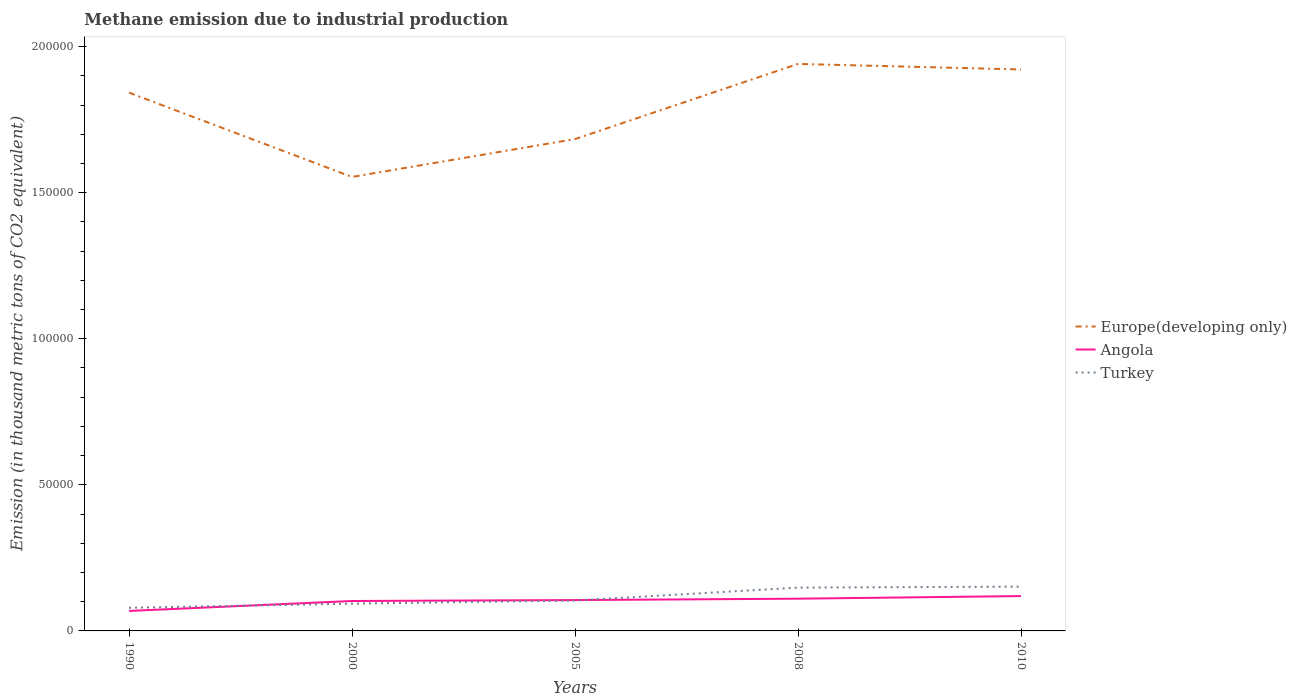How many different coloured lines are there?
Offer a terse response. 3. Does the line corresponding to Turkey intersect with the line corresponding to Angola?
Offer a terse response. Yes. Is the number of lines equal to the number of legend labels?
Your answer should be compact. Yes. Across all years, what is the maximum amount of methane emitted in Angola?
Make the answer very short. 6841.7. In which year was the amount of methane emitted in Europe(developing only) maximum?
Your answer should be very brief. 2000. What is the total amount of methane emitted in Europe(developing only) in the graph?
Your response must be concise. -9838.5. What is the difference between the highest and the second highest amount of methane emitted in Europe(developing only)?
Give a very brief answer. 3.87e+04. What is the difference between the highest and the lowest amount of methane emitted in Europe(developing only)?
Your response must be concise. 3. Are the values on the major ticks of Y-axis written in scientific E-notation?
Provide a succinct answer. No. Does the graph contain grids?
Provide a succinct answer. No. Where does the legend appear in the graph?
Your answer should be compact. Center right. How many legend labels are there?
Your answer should be very brief. 3. What is the title of the graph?
Give a very brief answer. Methane emission due to industrial production. Does "Pakistan" appear as one of the legend labels in the graph?
Your answer should be very brief. No. What is the label or title of the Y-axis?
Ensure brevity in your answer.  Emission (in thousand metric tons of CO2 equivalent). What is the Emission (in thousand metric tons of CO2 equivalent) in Europe(developing only) in 1990?
Ensure brevity in your answer.  1.84e+05. What is the Emission (in thousand metric tons of CO2 equivalent) of Angola in 1990?
Your answer should be compact. 6841.7. What is the Emission (in thousand metric tons of CO2 equivalent) of Turkey in 1990?
Ensure brevity in your answer.  7912.1. What is the Emission (in thousand metric tons of CO2 equivalent) in Europe(developing only) in 2000?
Provide a short and direct response. 1.55e+05. What is the Emission (in thousand metric tons of CO2 equivalent) of Angola in 2000?
Ensure brevity in your answer.  1.02e+04. What is the Emission (in thousand metric tons of CO2 equivalent) of Turkey in 2000?
Provide a short and direct response. 9337. What is the Emission (in thousand metric tons of CO2 equivalent) of Europe(developing only) in 2005?
Offer a very short reply. 1.68e+05. What is the Emission (in thousand metric tons of CO2 equivalent) of Angola in 2005?
Provide a succinct answer. 1.06e+04. What is the Emission (in thousand metric tons of CO2 equivalent) in Turkey in 2005?
Provide a succinct answer. 1.04e+04. What is the Emission (in thousand metric tons of CO2 equivalent) of Europe(developing only) in 2008?
Keep it short and to the point. 1.94e+05. What is the Emission (in thousand metric tons of CO2 equivalent) in Angola in 2008?
Provide a short and direct response. 1.10e+04. What is the Emission (in thousand metric tons of CO2 equivalent) of Turkey in 2008?
Your response must be concise. 1.48e+04. What is the Emission (in thousand metric tons of CO2 equivalent) in Europe(developing only) in 2010?
Your response must be concise. 1.92e+05. What is the Emission (in thousand metric tons of CO2 equivalent) of Angola in 2010?
Your response must be concise. 1.19e+04. What is the Emission (in thousand metric tons of CO2 equivalent) of Turkey in 2010?
Provide a short and direct response. 1.52e+04. Across all years, what is the maximum Emission (in thousand metric tons of CO2 equivalent) in Europe(developing only)?
Make the answer very short. 1.94e+05. Across all years, what is the maximum Emission (in thousand metric tons of CO2 equivalent) in Angola?
Ensure brevity in your answer.  1.19e+04. Across all years, what is the maximum Emission (in thousand metric tons of CO2 equivalent) in Turkey?
Your answer should be very brief. 1.52e+04. Across all years, what is the minimum Emission (in thousand metric tons of CO2 equivalent) of Europe(developing only)?
Offer a terse response. 1.55e+05. Across all years, what is the minimum Emission (in thousand metric tons of CO2 equivalent) in Angola?
Make the answer very short. 6841.7. Across all years, what is the minimum Emission (in thousand metric tons of CO2 equivalent) of Turkey?
Provide a succinct answer. 7912.1. What is the total Emission (in thousand metric tons of CO2 equivalent) of Europe(developing only) in the graph?
Your answer should be very brief. 8.94e+05. What is the total Emission (in thousand metric tons of CO2 equivalent) of Angola in the graph?
Give a very brief answer. 5.06e+04. What is the total Emission (in thousand metric tons of CO2 equivalent) in Turkey in the graph?
Ensure brevity in your answer.  5.76e+04. What is the difference between the Emission (in thousand metric tons of CO2 equivalent) in Europe(developing only) in 1990 and that in 2000?
Ensure brevity in your answer.  2.88e+04. What is the difference between the Emission (in thousand metric tons of CO2 equivalent) in Angola in 1990 and that in 2000?
Offer a very short reply. -3399.1. What is the difference between the Emission (in thousand metric tons of CO2 equivalent) of Turkey in 1990 and that in 2000?
Offer a terse response. -1424.9. What is the difference between the Emission (in thousand metric tons of CO2 equivalent) in Europe(developing only) in 1990 and that in 2005?
Your response must be concise. 1.59e+04. What is the difference between the Emission (in thousand metric tons of CO2 equivalent) of Angola in 1990 and that in 2005?
Make the answer very short. -3720.7. What is the difference between the Emission (in thousand metric tons of CO2 equivalent) of Turkey in 1990 and that in 2005?
Your response must be concise. -2494.3. What is the difference between the Emission (in thousand metric tons of CO2 equivalent) of Europe(developing only) in 1990 and that in 2008?
Your answer should be compact. -9838.5. What is the difference between the Emission (in thousand metric tons of CO2 equivalent) in Angola in 1990 and that in 2008?
Ensure brevity in your answer.  -4190.2. What is the difference between the Emission (in thousand metric tons of CO2 equivalent) of Turkey in 1990 and that in 2008?
Provide a succinct answer. -6910. What is the difference between the Emission (in thousand metric tons of CO2 equivalent) in Europe(developing only) in 1990 and that in 2010?
Offer a very short reply. -7940.9. What is the difference between the Emission (in thousand metric tons of CO2 equivalent) in Angola in 1990 and that in 2010?
Provide a short and direct response. -5084.3. What is the difference between the Emission (in thousand metric tons of CO2 equivalent) of Turkey in 1990 and that in 2010?
Your response must be concise. -7253.5. What is the difference between the Emission (in thousand metric tons of CO2 equivalent) of Europe(developing only) in 2000 and that in 2005?
Provide a short and direct response. -1.30e+04. What is the difference between the Emission (in thousand metric tons of CO2 equivalent) of Angola in 2000 and that in 2005?
Give a very brief answer. -321.6. What is the difference between the Emission (in thousand metric tons of CO2 equivalent) in Turkey in 2000 and that in 2005?
Your response must be concise. -1069.4. What is the difference between the Emission (in thousand metric tons of CO2 equivalent) of Europe(developing only) in 2000 and that in 2008?
Make the answer very short. -3.87e+04. What is the difference between the Emission (in thousand metric tons of CO2 equivalent) in Angola in 2000 and that in 2008?
Ensure brevity in your answer.  -791.1. What is the difference between the Emission (in thousand metric tons of CO2 equivalent) in Turkey in 2000 and that in 2008?
Your answer should be compact. -5485.1. What is the difference between the Emission (in thousand metric tons of CO2 equivalent) of Europe(developing only) in 2000 and that in 2010?
Give a very brief answer. -3.68e+04. What is the difference between the Emission (in thousand metric tons of CO2 equivalent) of Angola in 2000 and that in 2010?
Keep it short and to the point. -1685.2. What is the difference between the Emission (in thousand metric tons of CO2 equivalent) of Turkey in 2000 and that in 2010?
Offer a terse response. -5828.6. What is the difference between the Emission (in thousand metric tons of CO2 equivalent) in Europe(developing only) in 2005 and that in 2008?
Make the answer very short. -2.57e+04. What is the difference between the Emission (in thousand metric tons of CO2 equivalent) of Angola in 2005 and that in 2008?
Make the answer very short. -469.5. What is the difference between the Emission (in thousand metric tons of CO2 equivalent) of Turkey in 2005 and that in 2008?
Make the answer very short. -4415.7. What is the difference between the Emission (in thousand metric tons of CO2 equivalent) of Europe(developing only) in 2005 and that in 2010?
Offer a terse response. -2.38e+04. What is the difference between the Emission (in thousand metric tons of CO2 equivalent) of Angola in 2005 and that in 2010?
Your answer should be very brief. -1363.6. What is the difference between the Emission (in thousand metric tons of CO2 equivalent) in Turkey in 2005 and that in 2010?
Ensure brevity in your answer.  -4759.2. What is the difference between the Emission (in thousand metric tons of CO2 equivalent) of Europe(developing only) in 2008 and that in 2010?
Provide a short and direct response. 1897.6. What is the difference between the Emission (in thousand metric tons of CO2 equivalent) of Angola in 2008 and that in 2010?
Offer a very short reply. -894.1. What is the difference between the Emission (in thousand metric tons of CO2 equivalent) of Turkey in 2008 and that in 2010?
Your answer should be compact. -343.5. What is the difference between the Emission (in thousand metric tons of CO2 equivalent) in Europe(developing only) in 1990 and the Emission (in thousand metric tons of CO2 equivalent) in Angola in 2000?
Make the answer very short. 1.74e+05. What is the difference between the Emission (in thousand metric tons of CO2 equivalent) in Europe(developing only) in 1990 and the Emission (in thousand metric tons of CO2 equivalent) in Turkey in 2000?
Your response must be concise. 1.75e+05. What is the difference between the Emission (in thousand metric tons of CO2 equivalent) in Angola in 1990 and the Emission (in thousand metric tons of CO2 equivalent) in Turkey in 2000?
Your answer should be very brief. -2495.3. What is the difference between the Emission (in thousand metric tons of CO2 equivalent) in Europe(developing only) in 1990 and the Emission (in thousand metric tons of CO2 equivalent) in Angola in 2005?
Give a very brief answer. 1.74e+05. What is the difference between the Emission (in thousand metric tons of CO2 equivalent) in Europe(developing only) in 1990 and the Emission (in thousand metric tons of CO2 equivalent) in Turkey in 2005?
Make the answer very short. 1.74e+05. What is the difference between the Emission (in thousand metric tons of CO2 equivalent) of Angola in 1990 and the Emission (in thousand metric tons of CO2 equivalent) of Turkey in 2005?
Provide a short and direct response. -3564.7. What is the difference between the Emission (in thousand metric tons of CO2 equivalent) of Europe(developing only) in 1990 and the Emission (in thousand metric tons of CO2 equivalent) of Angola in 2008?
Provide a short and direct response. 1.73e+05. What is the difference between the Emission (in thousand metric tons of CO2 equivalent) in Europe(developing only) in 1990 and the Emission (in thousand metric tons of CO2 equivalent) in Turkey in 2008?
Provide a succinct answer. 1.69e+05. What is the difference between the Emission (in thousand metric tons of CO2 equivalent) of Angola in 1990 and the Emission (in thousand metric tons of CO2 equivalent) of Turkey in 2008?
Make the answer very short. -7980.4. What is the difference between the Emission (in thousand metric tons of CO2 equivalent) of Europe(developing only) in 1990 and the Emission (in thousand metric tons of CO2 equivalent) of Angola in 2010?
Your answer should be compact. 1.72e+05. What is the difference between the Emission (in thousand metric tons of CO2 equivalent) of Europe(developing only) in 1990 and the Emission (in thousand metric tons of CO2 equivalent) of Turkey in 2010?
Provide a short and direct response. 1.69e+05. What is the difference between the Emission (in thousand metric tons of CO2 equivalent) in Angola in 1990 and the Emission (in thousand metric tons of CO2 equivalent) in Turkey in 2010?
Offer a very short reply. -8323.9. What is the difference between the Emission (in thousand metric tons of CO2 equivalent) of Europe(developing only) in 2000 and the Emission (in thousand metric tons of CO2 equivalent) of Angola in 2005?
Make the answer very short. 1.45e+05. What is the difference between the Emission (in thousand metric tons of CO2 equivalent) in Europe(developing only) in 2000 and the Emission (in thousand metric tons of CO2 equivalent) in Turkey in 2005?
Your response must be concise. 1.45e+05. What is the difference between the Emission (in thousand metric tons of CO2 equivalent) in Angola in 2000 and the Emission (in thousand metric tons of CO2 equivalent) in Turkey in 2005?
Your answer should be very brief. -165.6. What is the difference between the Emission (in thousand metric tons of CO2 equivalent) of Europe(developing only) in 2000 and the Emission (in thousand metric tons of CO2 equivalent) of Angola in 2008?
Give a very brief answer. 1.44e+05. What is the difference between the Emission (in thousand metric tons of CO2 equivalent) of Europe(developing only) in 2000 and the Emission (in thousand metric tons of CO2 equivalent) of Turkey in 2008?
Provide a short and direct response. 1.41e+05. What is the difference between the Emission (in thousand metric tons of CO2 equivalent) in Angola in 2000 and the Emission (in thousand metric tons of CO2 equivalent) in Turkey in 2008?
Offer a terse response. -4581.3. What is the difference between the Emission (in thousand metric tons of CO2 equivalent) of Europe(developing only) in 2000 and the Emission (in thousand metric tons of CO2 equivalent) of Angola in 2010?
Give a very brief answer. 1.43e+05. What is the difference between the Emission (in thousand metric tons of CO2 equivalent) of Europe(developing only) in 2000 and the Emission (in thousand metric tons of CO2 equivalent) of Turkey in 2010?
Your response must be concise. 1.40e+05. What is the difference between the Emission (in thousand metric tons of CO2 equivalent) of Angola in 2000 and the Emission (in thousand metric tons of CO2 equivalent) of Turkey in 2010?
Your answer should be compact. -4924.8. What is the difference between the Emission (in thousand metric tons of CO2 equivalent) in Europe(developing only) in 2005 and the Emission (in thousand metric tons of CO2 equivalent) in Angola in 2008?
Offer a very short reply. 1.57e+05. What is the difference between the Emission (in thousand metric tons of CO2 equivalent) of Europe(developing only) in 2005 and the Emission (in thousand metric tons of CO2 equivalent) of Turkey in 2008?
Offer a very short reply. 1.54e+05. What is the difference between the Emission (in thousand metric tons of CO2 equivalent) of Angola in 2005 and the Emission (in thousand metric tons of CO2 equivalent) of Turkey in 2008?
Make the answer very short. -4259.7. What is the difference between the Emission (in thousand metric tons of CO2 equivalent) in Europe(developing only) in 2005 and the Emission (in thousand metric tons of CO2 equivalent) in Angola in 2010?
Provide a succinct answer. 1.56e+05. What is the difference between the Emission (in thousand metric tons of CO2 equivalent) in Europe(developing only) in 2005 and the Emission (in thousand metric tons of CO2 equivalent) in Turkey in 2010?
Your answer should be very brief. 1.53e+05. What is the difference between the Emission (in thousand metric tons of CO2 equivalent) of Angola in 2005 and the Emission (in thousand metric tons of CO2 equivalent) of Turkey in 2010?
Offer a terse response. -4603.2. What is the difference between the Emission (in thousand metric tons of CO2 equivalent) of Europe(developing only) in 2008 and the Emission (in thousand metric tons of CO2 equivalent) of Angola in 2010?
Provide a short and direct response. 1.82e+05. What is the difference between the Emission (in thousand metric tons of CO2 equivalent) in Europe(developing only) in 2008 and the Emission (in thousand metric tons of CO2 equivalent) in Turkey in 2010?
Make the answer very short. 1.79e+05. What is the difference between the Emission (in thousand metric tons of CO2 equivalent) in Angola in 2008 and the Emission (in thousand metric tons of CO2 equivalent) in Turkey in 2010?
Your answer should be very brief. -4133.7. What is the average Emission (in thousand metric tons of CO2 equivalent) of Europe(developing only) per year?
Your answer should be compact. 1.79e+05. What is the average Emission (in thousand metric tons of CO2 equivalent) in Angola per year?
Make the answer very short. 1.01e+04. What is the average Emission (in thousand metric tons of CO2 equivalent) of Turkey per year?
Make the answer very short. 1.15e+04. In the year 1990, what is the difference between the Emission (in thousand metric tons of CO2 equivalent) in Europe(developing only) and Emission (in thousand metric tons of CO2 equivalent) in Angola?
Keep it short and to the point. 1.77e+05. In the year 1990, what is the difference between the Emission (in thousand metric tons of CO2 equivalent) in Europe(developing only) and Emission (in thousand metric tons of CO2 equivalent) in Turkey?
Make the answer very short. 1.76e+05. In the year 1990, what is the difference between the Emission (in thousand metric tons of CO2 equivalent) of Angola and Emission (in thousand metric tons of CO2 equivalent) of Turkey?
Your answer should be very brief. -1070.4. In the year 2000, what is the difference between the Emission (in thousand metric tons of CO2 equivalent) in Europe(developing only) and Emission (in thousand metric tons of CO2 equivalent) in Angola?
Provide a short and direct response. 1.45e+05. In the year 2000, what is the difference between the Emission (in thousand metric tons of CO2 equivalent) of Europe(developing only) and Emission (in thousand metric tons of CO2 equivalent) of Turkey?
Make the answer very short. 1.46e+05. In the year 2000, what is the difference between the Emission (in thousand metric tons of CO2 equivalent) in Angola and Emission (in thousand metric tons of CO2 equivalent) in Turkey?
Your answer should be very brief. 903.8. In the year 2005, what is the difference between the Emission (in thousand metric tons of CO2 equivalent) in Europe(developing only) and Emission (in thousand metric tons of CO2 equivalent) in Angola?
Offer a very short reply. 1.58e+05. In the year 2005, what is the difference between the Emission (in thousand metric tons of CO2 equivalent) in Europe(developing only) and Emission (in thousand metric tons of CO2 equivalent) in Turkey?
Offer a terse response. 1.58e+05. In the year 2005, what is the difference between the Emission (in thousand metric tons of CO2 equivalent) of Angola and Emission (in thousand metric tons of CO2 equivalent) of Turkey?
Ensure brevity in your answer.  156. In the year 2008, what is the difference between the Emission (in thousand metric tons of CO2 equivalent) in Europe(developing only) and Emission (in thousand metric tons of CO2 equivalent) in Angola?
Ensure brevity in your answer.  1.83e+05. In the year 2008, what is the difference between the Emission (in thousand metric tons of CO2 equivalent) in Europe(developing only) and Emission (in thousand metric tons of CO2 equivalent) in Turkey?
Make the answer very short. 1.79e+05. In the year 2008, what is the difference between the Emission (in thousand metric tons of CO2 equivalent) in Angola and Emission (in thousand metric tons of CO2 equivalent) in Turkey?
Offer a very short reply. -3790.2. In the year 2010, what is the difference between the Emission (in thousand metric tons of CO2 equivalent) in Europe(developing only) and Emission (in thousand metric tons of CO2 equivalent) in Angola?
Make the answer very short. 1.80e+05. In the year 2010, what is the difference between the Emission (in thousand metric tons of CO2 equivalent) in Europe(developing only) and Emission (in thousand metric tons of CO2 equivalent) in Turkey?
Offer a very short reply. 1.77e+05. In the year 2010, what is the difference between the Emission (in thousand metric tons of CO2 equivalent) of Angola and Emission (in thousand metric tons of CO2 equivalent) of Turkey?
Make the answer very short. -3239.6. What is the ratio of the Emission (in thousand metric tons of CO2 equivalent) of Europe(developing only) in 1990 to that in 2000?
Keep it short and to the point. 1.19. What is the ratio of the Emission (in thousand metric tons of CO2 equivalent) in Angola in 1990 to that in 2000?
Keep it short and to the point. 0.67. What is the ratio of the Emission (in thousand metric tons of CO2 equivalent) in Turkey in 1990 to that in 2000?
Your answer should be very brief. 0.85. What is the ratio of the Emission (in thousand metric tons of CO2 equivalent) of Europe(developing only) in 1990 to that in 2005?
Ensure brevity in your answer.  1.09. What is the ratio of the Emission (in thousand metric tons of CO2 equivalent) of Angola in 1990 to that in 2005?
Offer a very short reply. 0.65. What is the ratio of the Emission (in thousand metric tons of CO2 equivalent) of Turkey in 1990 to that in 2005?
Give a very brief answer. 0.76. What is the ratio of the Emission (in thousand metric tons of CO2 equivalent) of Europe(developing only) in 1990 to that in 2008?
Your response must be concise. 0.95. What is the ratio of the Emission (in thousand metric tons of CO2 equivalent) in Angola in 1990 to that in 2008?
Your answer should be very brief. 0.62. What is the ratio of the Emission (in thousand metric tons of CO2 equivalent) in Turkey in 1990 to that in 2008?
Your answer should be compact. 0.53. What is the ratio of the Emission (in thousand metric tons of CO2 equivalent) of Europe(developing only) in 1990 to that in 2010?
Your answer should be compact. 0.96. What is the ratio of the Emission (in thousand metric tons of CO2 equivalent) of Angola in 1990 to that in 2010?
Offer a terse response. 0.57. What is the ratio of the Emission (in thousand metric tons of CO2 equivalent) of Turkey in 1990 to that in 2010?
Give a very brief answer. 0.52. What is the ratio of the Emission (in thousand metric tons of CO2 equivalent) in Europe(developing only) in 2000 to that in 2005?
Give a very brief answer. 0.92. What is the ratio of the Emission (in thousand metric tons of CO2 equivalent) of Angola in 2000 to that in 2005?
Keep it short and to the point. 0.97. What is the ratio of the Emission (in thousand metric tons of CO2 equivalent) of Turkey in 2000 to that in 2005?
Your answer should be compact. 0.9. What is the ratio of the Emission (in thousand metric tons of CO2 equivalent) of Europe(developing only) in 2000 to that in 2008?
Make the answer very short. 0.8. What is the ratio of the Emission (in thousand metric tons of CO2 equivalent) of Angola in 2000 to that in 2008?
Make the answer very short. 0.93. What is the ratio of the Emission (in thousand metric tons of CO2 equivalent) in Turkey in 2000 to that in 2008?
Make the answer very short. 0.63. What is the ratio of the Emission (in thousand metric tons of CO2 equivalent) in Europe(developing only) in 2000 to that in 2010?
Ensure brevity in your answer.  0.81. What is the ratio of the Emission (in thousand metric tons of CO2 equivalent) in Angola in 2000 to that in 2010?
Ensure brevity in your answer.  0.86. What is the ratio of the Emission (in thousand metric tons of CO2 equivalent) of Turkey in 2000 to that in 2010?
Offer a very short reply. 0.62. What is the ratio of the Emission (in thousand metric tons of CO2 equivalent) of Europe(developing only) in 2005 to that in 2008?
Keep it short and to the point. 0.87. What is the ratio of the Emission (in thousand metric tons of CO2 equivalent) of Angola in 2005 to that in 2008?
Provide a succinct answer. 0.96. What is the ratio of the Emission (in thousand metric tons of CO2 equivalent) in Turkey in 2005 to that in 2008?
Offer a terse response. 0.7. What is the ratio of the Emission (in thousand metric tons of CO2 equivalent) in Europe(developing only) in 2005 to that in 2010?
Make the answer very short. 0.88. What is the ratio of the Emission (in thousand metric tons of CO2 equivalent) of Angola in 2005 to that in 2010?
Your answer should be compact. 0.89. What is the ratio of the Emission (in thousand metric tons of CO2 equivalent) of Turkey in 2005 to that in 2010?
Your answer should be very brief. 0.69. What is the ratio of the Emission (in thousand metric tons of CO2 equivalent) of Europe(developing only) in 2008 to that in 2010?
Offer a very short reply. 1.01. What is the ratio of the Emission (in thousand metric tons of CO2 equivalent) of Angola in 2008 to that in 2010?
Ensure brevity in your answer.  0.93. What is the ratio of the Emission (in thousand metric tons of CO2 equivalent) of Turkey in 2008 to that in 2010?
Keep it short and to the point. 0.98. What is the difference between the highest and the second highest Emission (in thousand metric tons of CO2 equivalent) of Europe(developing only)?
Provide a succinct answer. 1897.6. What is the difference between the highest and the second highest Emission (in thousand metric tons of CO2 equivalent) in Angola?
Keep it short and to the point. 894.1. What is the difference between the highest and the second highest Emission (in thousand metric tons of CO2 equivalent) of Turkey?
Keep it short and to the point. 343.5. What is the difference between the highest and the lowest Emission (in thousand metric tons of CO2 equivalent) of Europe(developing only)?
Provide a short and direct response. 3.87e+04. What is the difference between the highest and the lowest Emission (in thousand metric tons of CO2 equivalent) of Angola?
Provide a short and direct response. 5084.3. What is the difference between the highest and the lowest Emission (in thousand metric tons of CO2 equivalent) in Turkey?
Offer a terse response. 7253.5. 